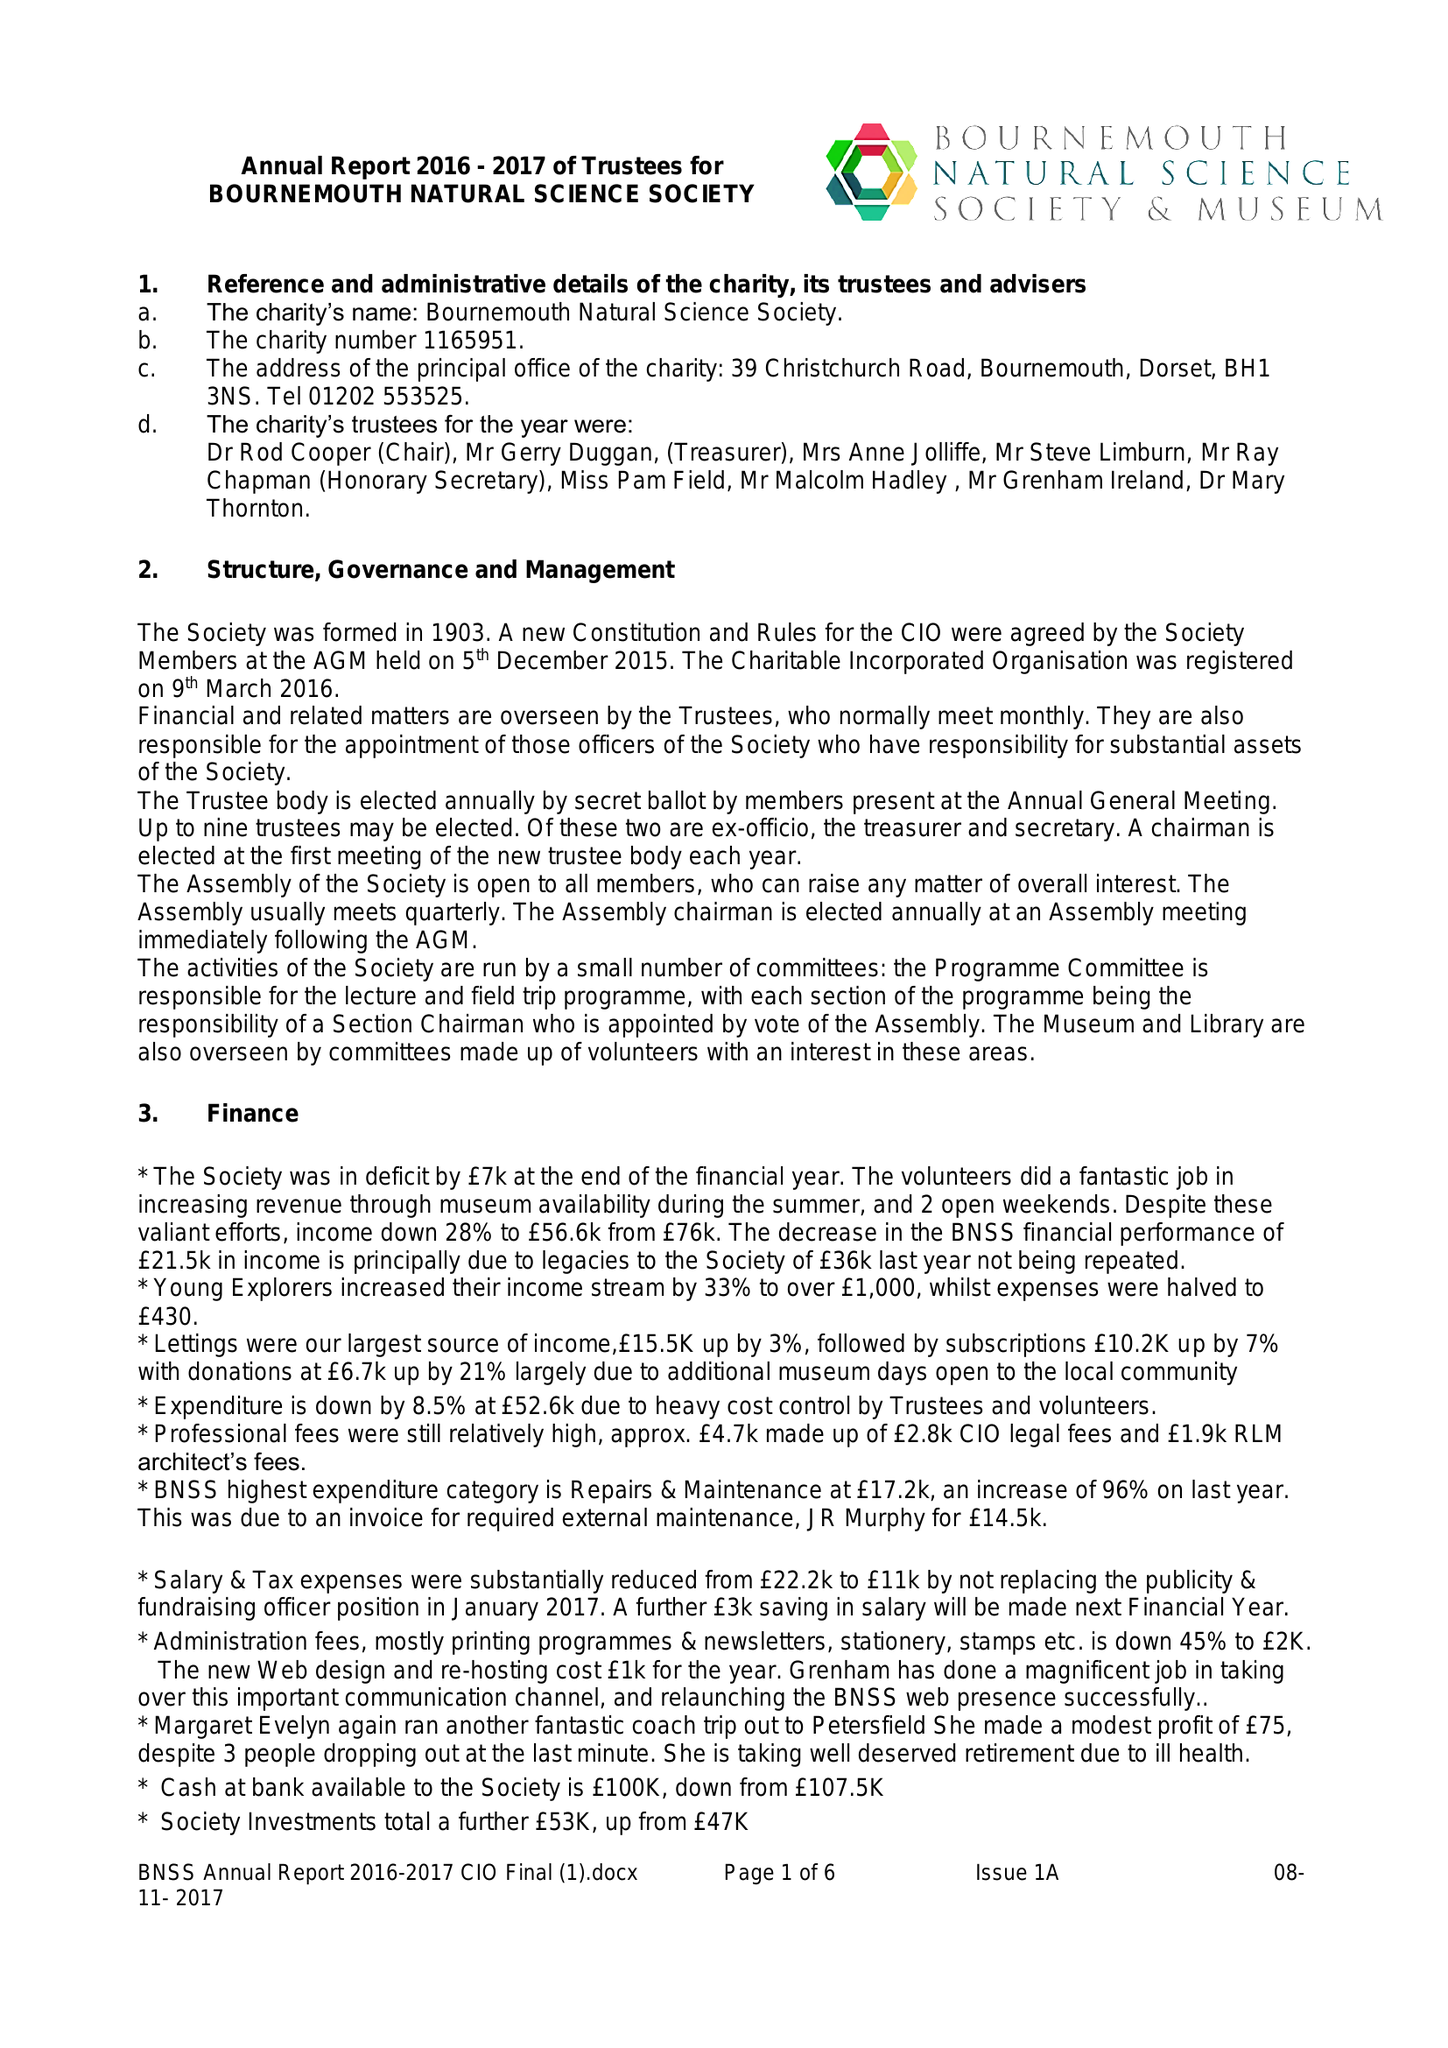What is the value for the income_annually_in_british_pounds?
Answer the question using a single word or phrase. 45536.00 